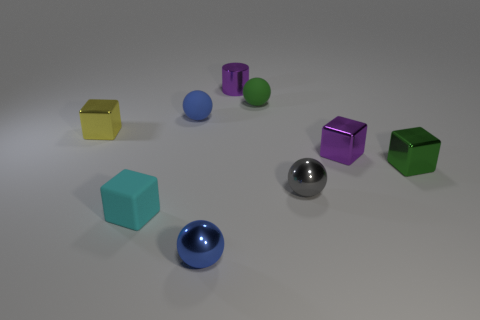Is the tiny green thing on the left side of the tiny gray thing made of the same material as the small green cube?
Offer a very short reply. No. Do the small green object that is in front of the tiny green matte ball and the tiny purple thing in front of the yellow cube have the same shape?
Give a very brief answer. Yes. There is a small rubber object right of the small metal object that is in front of the small cyan matte cube; what is its color?
Ensure brevity in your answer.  Green. Are there any metal balls that have the same color as the small cylinder?
Provide a short and direct response. No. The green shiny thing that is the same size as the gray thing is what shape?
Your answer should be very brief. Cube. There is a small shiny block on the left side of the cyan thing; how many green metallic cubes are to the right of it?
Your answer should be very brief. 1. What number of other objects are the same material as the yellow cube?
Ensure brevity in your answer.  5. There is a small metal object behind the small metal cube that is left of the small cylinder; what shape is it?
Provide a short and direct response. Cylinder. Is the material of the green ball the same as the cyan block?
Provide a succinct answer. Yes. There is a gray object that is the same material as the small yellow block; what is its shape?
Offer a very short reply. Sphere. 